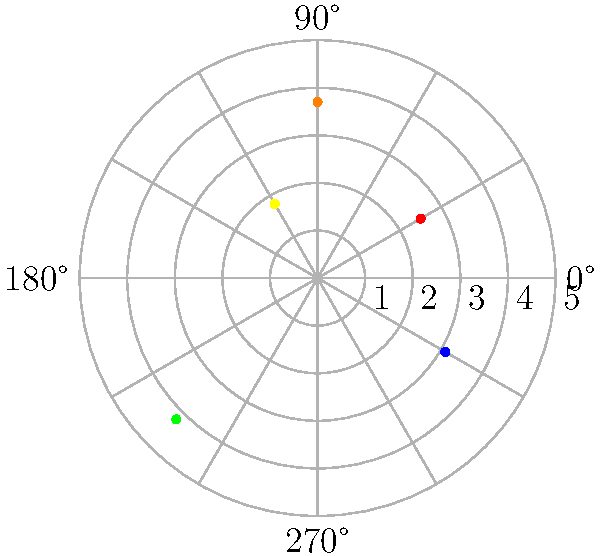As an app developer, you're analyzing user interaction data on a circular interface. The data is plotted on a polar coordinate heat map, where the angle represents the position on the circular interface, and the distance from the center indicates the frequency of interactions. Given the heat map above, which quadrant shows the highest concentration of user interactions, and what does this suggest about user behavior? To answer this question, we need to analyze the heat map data points plotted on the polar coordinate system. Let's break it down step-by-step:

1. Identify the quadrants:
   - Quadrant I: 0° to 90°
   - Quadrant II: 90° to 180°
   - Quadrant III: 180° to 270°
   - Quadrant IV: 270° to 360° (0°)

2. Analyze the data points:
   - Red point: (r, θ) ≈ (2.5, 30°) - Quadrant I
   - Orange point: (r, θ) ≈ (3.7, 90°) - Border of Quadrants I and II
   - Yellow point: (r, θ) ≈ (1.8, 120°) - Quadrant II
   - Green point: (r, θ) ≈ (4.2, 225°) - Quadrant III
   - Blue point: (r, θ) ≈ (3.1, 330°) - Quadrant IV

3. Evaluate the concentration:
   - Quadrant I has two points (including the border point)
   - Quadrant II has two points (including the border point)
   - Quadrant III has one point
   - Quadrant IV has one point

4. Determine the highest concentration:
   Quadrants I and II have the highest number of points. However, the points in Quadrant I (including the border) have larger r values, indicating higher frequency of interactions.

5. Interpret user behavior:
   The concentration of interactions in Quadrant I suggests that users interact more frequently with the top-right portion of the circular interface. This could indicate that important features or frequently used elements are located in this area.
Answer: Quadrant I; users interact more with the top-right portion of the interface. 